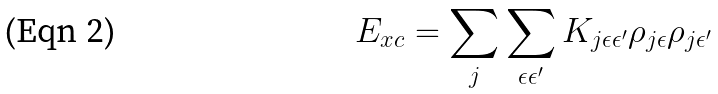<formula> <loc_0><loc_0><loc_500><loc_500>E _ { x c } = \sum _ { j } \sum _ { \epsilon \epsilon ^ { \prime } } K _ { j \epsilon \epsilon ^ { \prime } } \rho _ { j \epsilon } \rho _ { j \epsilon ^ { \prime } }</formula> 